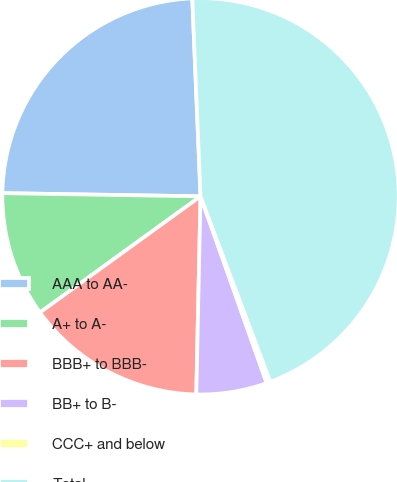<chart> <loc_0><loc_0><loc_500><loc_500><pie_chart><fcel>AAA to AA-<fcel>A+ to A-<fcel>BBB+ to BBB-<fcel>BB+ to B-<fcel>CCC+ and below<fcel>Total<nl><fcel>24.08%<fcel>10.22%<fcel>14.69%<fcel>5.76%<fcel>0.31%<fcel>44.93%<nl></chart> 